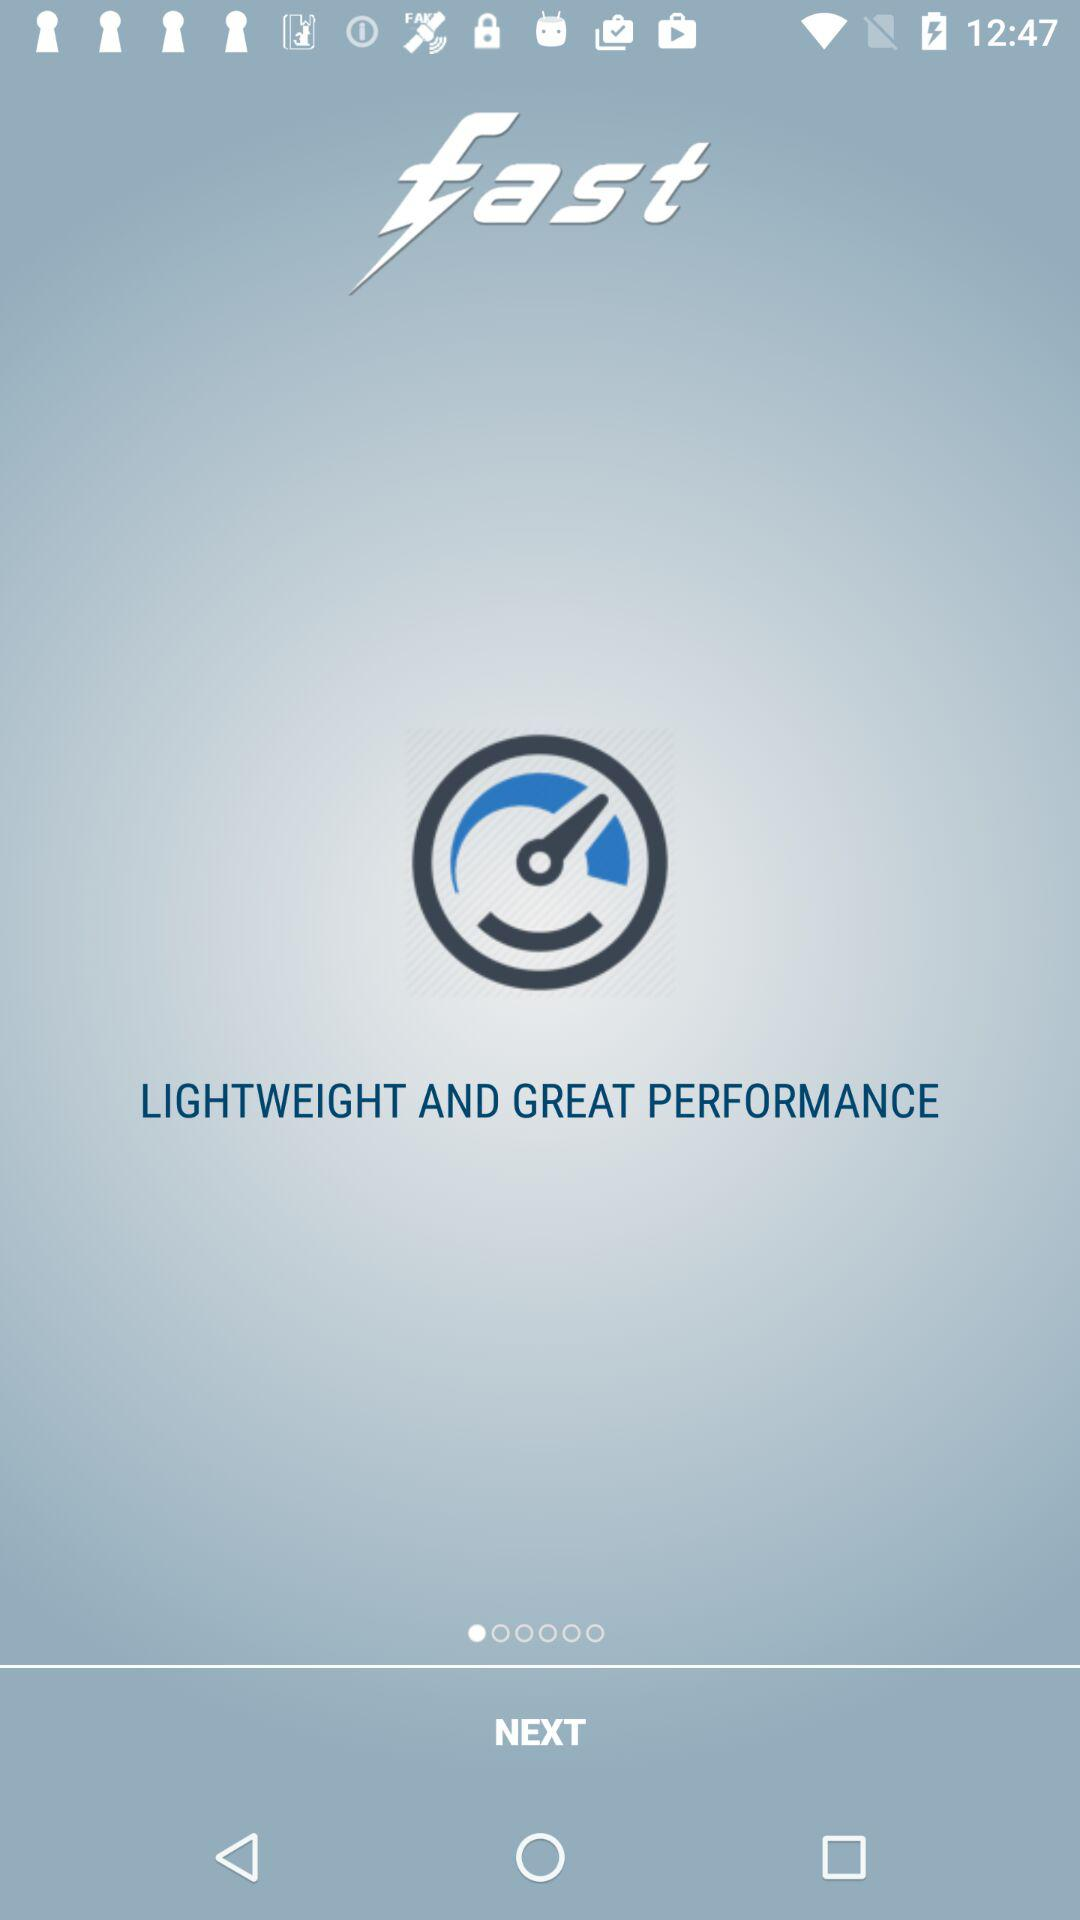What is the name of the application? The name of the application is "fast". 